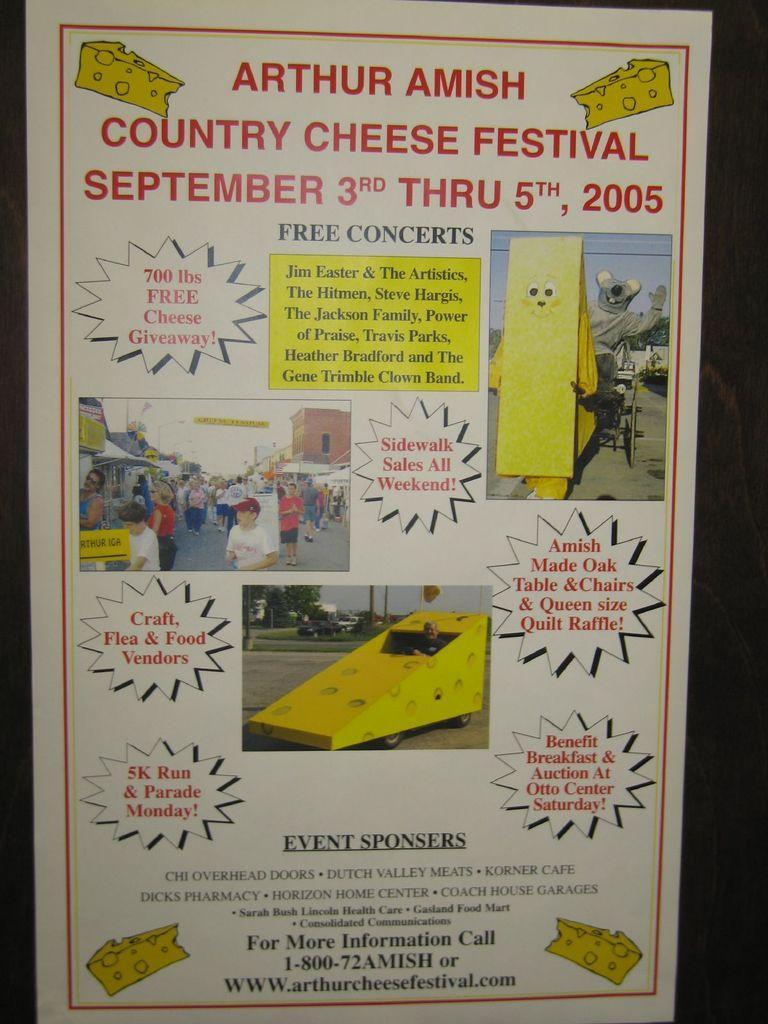In one or two sentences, can you explain what this image depicts? In this image we can see a poster. In the poster we can see the text and images. In the images we can see persons. 